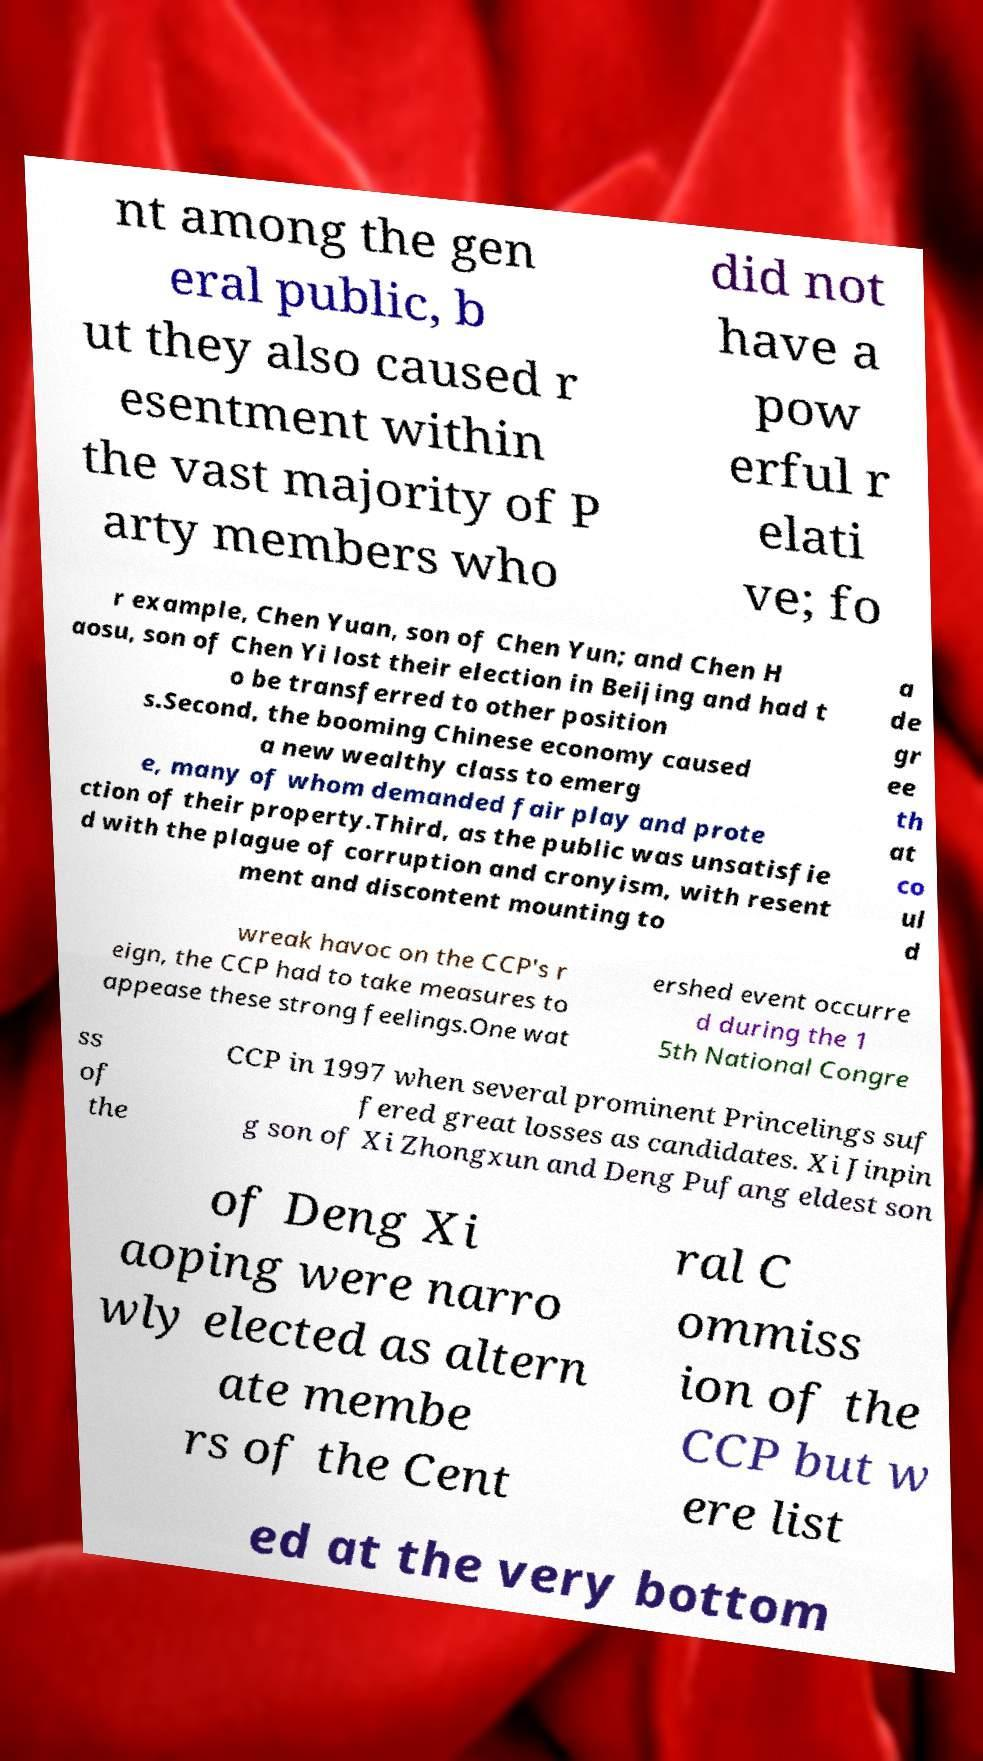Can you accurately transcribe the text from the provided image for me? nt among the gen eral public, b ut they also caused r esentment within the vast majority of P arty members who did not have a pow erful r elati ve; fo r example, Chen Yuan, son of Chen Yun; and Chen H aosu, son of Chen Yi lost their election in Beijing and had t o be transferred to other position s.Second, the booming Chinese economy caused a new wealthy class to emerg e, many of whom demanded fair play and prote ction of their property.Third, as the public was unsatisfie d with the plague of corruption and cronyism, with resent ment and discontent mounting to a de gr ee th at co ul d wreak havoc on the CCP's r eign, the CCP had to take measures to appease these strong feelings.One wat ershed event occurre d during the 1 5th National Congre ss of the CCP in 1997 when several prominent Princelings suf fered great losses as candidates. Xi Jinpin g son of Xi Zhongxun and Deng Pufang eldest son of Deng Xi aoping were narro wly elected as altern ate membe rs of the Cent ral C ommiss ion of the CCP but w ere list ed at the very bottom 